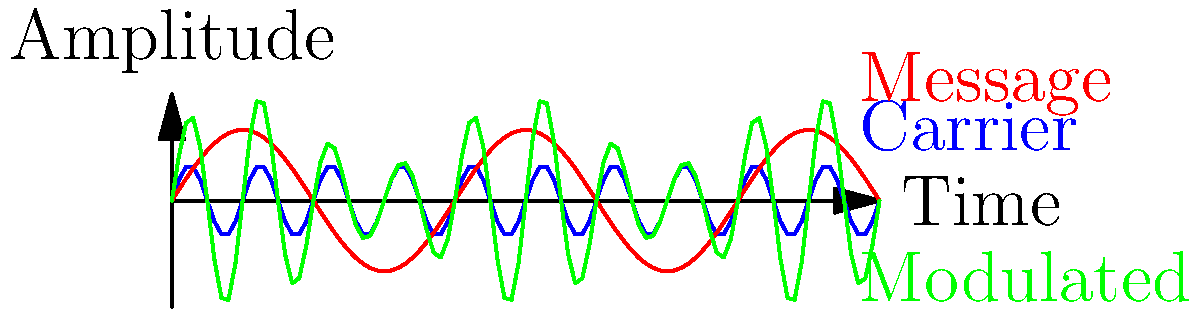As a chemical engineer working on synthetic leather production, you encounter a process control system that uses amplitude modulation (AM) for signal transmission. The figure shows time-domain representations of a carrier signal (blue), message signal (red), and the resulting modulated signal (green). What is the modulation index of this AM signal, and how would this affect the bandwidth of the transmitted signal compared to the message signal's bandwidth? To solve this problem, let's follow these steps:

1. Recall that the modulation index (m) for AM is defined as:
   $$ m = \frac{A_m}{A_c} $$
   where $A_m$ is the amplitude of the message signal and $A_c$ is the amplitude of the carrier signal.

2. From the graph, we can observe:
   - The carrier signal (blue) has an amplitude of 0.5
   - The message signal (red) has an amplitude of 1
   - The modulated signal (green) varies between 0.5 and 1.5

3. The modulated signal's envelope represents the sum of the carrier amplitude and the message signal. Its maximum amplitude is:
   $$ A_c + A_m = 1.5 $$
   And its minimum amplitude is:
   $$ A_c - A_m = 0.5 $$

4. We can calculate the modulation index:
   $$ m = \frac{A_m}{A_c} = \frac{1}{0.5} = 2 $$

5. For bandwidth consideration:
   - In AM, the bandwidth of the transmitted signal is twice the highest frequency component of the message signal.
   - The modulation index doesn't directly affect the bandwidth, but it affects the power distribution in the sidebands.
   - With m = 2 (which is > 1), this is a case of over-modulation, which can lead to distortion and increased bandwidth due to additional harmonic components.

6. In practice, for efficient AM transmission without distortion, m should be kept ≤ 1. In this case, m = 2 indicates over-modulation, which would result in a wider bandwidth than necessary and potential signal distortion.
Answer: Modulation index = 2; Over-modulation leading to increased bandwidth and potential distortion. 